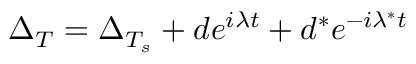<formula> <loc_0><loc_0><loc_500><loc_500>\Delta _ { T } = \Delta _ { T _ { s } } + d e ^ { i \lambda t } + d ^ { * } e ^ { - i \lambda ^ { * } t }</formula> 